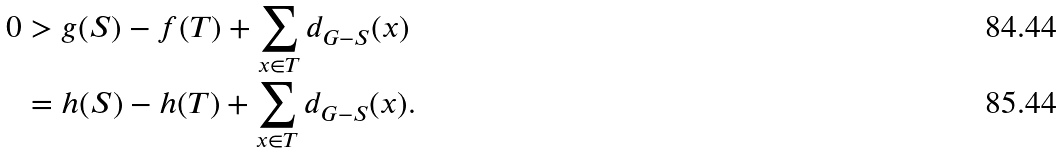Convert formula to latex. <formula><loc_0><loc_0><loc_500><loc_500>0 & > g ( S ) - f ( T ) + \sum _ { x \in T } d _ { G - S } ( x ) \\ & = h ( S ) - h ( T ) + \sum _ { x \in T } d _ { G - S } ( x ) .</formula> 